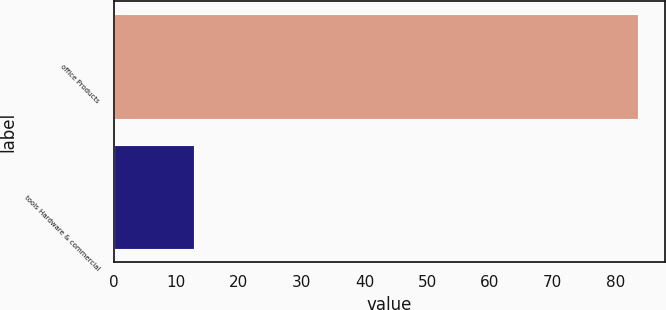<chart> <loc_0><loc_0><loc_500><loc_500><bar_chart><fcel>office Products<fcel>tools Hardware & commercial<nl><fcel>83.7<fcel>12.9<nl></chart> 